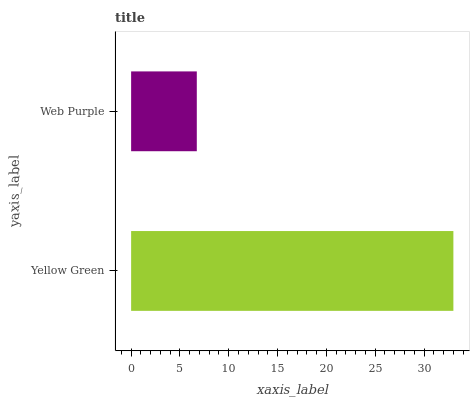Is Web Purple the minimum?
Answer yes or no. Yes. Is Yellow Green the maximum?
Answer yes or no. Yes. Is Web Purple the maximum?
Answer yes or no. No. Is Yellow Green greater than Web Purple?
Answer yes or no. Yes. Is Web Purple less than Yellow Green?
Answer yes or no. Yes. Is Web Purple greater than Yellow Green?
Answer yes or no. No. Is Yellow Green less than Web Purple?
Answer yes or no. No. Is Yellow Green the high median?
Answer yes or no. Yes. Is Web Purple the low median?
Answer yes or no. Yes. Is Web Purple the high median?
Answer yes or no. No. Is Yellow Green the low median?
Answer yes or no. No. 